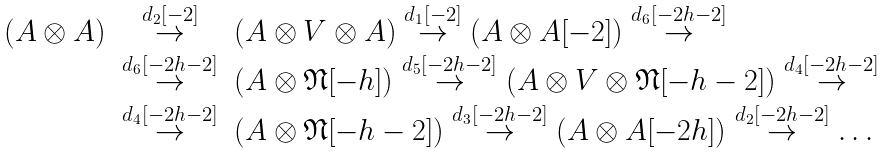Convert formula to latex. <formula><loc_0><loc_0><loc_500><loc_500>\begin{array} { r c l } ( A \otimes A ) & \stackrel { d _ { 2 } [ - 2 ] } { \rightarrow } & ( A \otimes V \otimes A ) \stackrel { d _ { 1 } [ - 2 ] } { \rightarrow } ( A \otimes A [ - 2 ] ) \stackrel { d _ { 6 } [ - 2 h - 2 ] } { \rightarrow } \\ & \stackrel { d _ { 6 } [ - 2 h - 2 ] } { \rightarrow } & ( A \otimes \mathfrak { N } [ - h ] ) \stackrel { d _ { 5 } [ - 2 h - 2 ] } { \rightarrow } ( A \otimes V \otimes \mathfrak { N } [ - h - 2 ] ) \stackrel { d _ { 4 } [ - 2 h - 2 ] } { \rightarrow } \\ & \stackrel { d _ { 4 } [ - 2 h - 2 ] } { \rightarrow } & ( A \otimes \mathfrak { N } [ - h - 2 ] ) \stackrel { d _ { 3 } [ - 2 h - 2 ] } { \rightarrow } ( A \otimes A [ - 2 h ] ) \stackrel { d _ { 2 } [ - 2 h - 2 ] } { \rightarrow } \dots \end{array}</formula> 